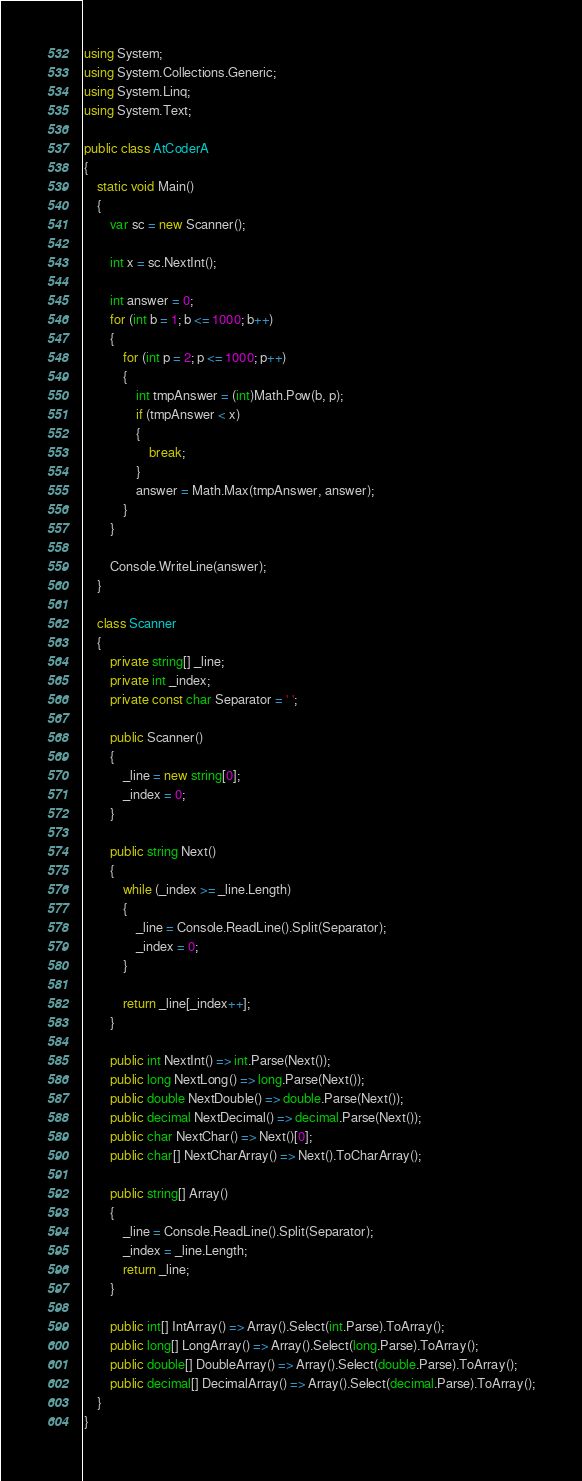Convert code to text. <code><loc_0><loc_0><loc_500><loc_500><_C#_>using System;
using System.Collections.Generic;
using System.Linq;
using System.Text;

public class AtCoderA
{
    static void Main()
    {
        var sc = new Scanner();

        int x = sc.NextInt();

        int answer = 0;
        for (int b = 1; b <= 1000; b++)
        {
            for (int p = 2; p <= 1000; p++)
            {
                int tmpAnswer = (int)Math.Pow(b, p);
                if (tmpAnswer < x)
                {
                    break;
                }
                answer = Math.Max(tmpAnswer, answer);
            }
        }

        Console.WriteLine(answer);
    }

    class Scanner
    {
        private string[] _line;
        private int _index;
        private const char Separator = ' ';

        public Scanner()
        {
            _line = new string[0];
            _index = 0;
        }

        public string Next()
        {
            while (_index >= _line.Length)
            {
                _line = Console.ReadLine().Split(Separator);
                _index = 0;
            }

            return _line[_index++];
        }

        public int NextInt() => int.Parse(Next());
        public long NextLong() => long.Parse(Next());
        public double NextDouble() => double.Parse(Next());
        public decimal NextDecimal() => decimal.Parse(Next());
        public char NextChar() => Next()[0];
        public char[] NextCharArray() => Next().ToCharArray();

        public string[] Array()
        {
            _line = Console.ReadLine().Split(Separator);
            _index = _line.Length;
            return _line;
        }

        public int[] IntArray() => Array().Select(int.Parse).ToArray();
        public long[] LongArray() => Array().Select(long.Parse).ToArray();
        public double[] DoubleArray() => Array().Select(double.Parse).ToArray();
        public decimal[] DecimalArray() => Array().Select(decimal.Parse).ToArray();
    }
}</code> 